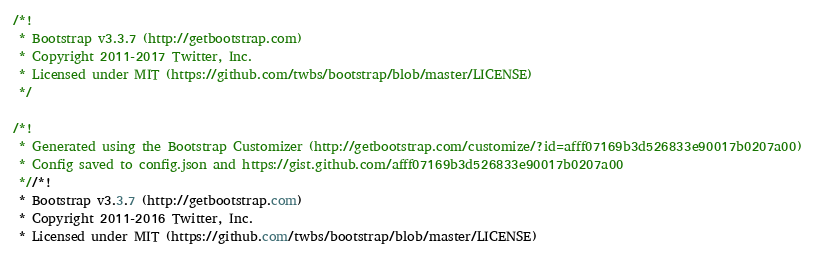<code> <loc_0><loc_0><loc_500><loc_500><_CSS_>/*!
 * Bootstrap v3.3.7 (http://getbootstrap.com)
 * Copyright 2011-2017 Twitter, Inc.
 * Licensed under MIT (https://github.com/twbs/bootstrap/blob/master/LICENSE)
 */

/*!
 * Generated using the Bootstrap Customizer (http://getbootstrap.com/customize/?id=afff07169b3d526833e90017b0207a00)
 * Config saved to config.json and https://gist.github.com/afff07169b3d526833e90017b0207a00
 *//*!
 * Bootstrap v3.3.7 (http://getbootstrap.com)
 * Copyright 2011-2016 Twitter, Inc.
 * Licensed under MIT (https://github.com/twbs/bootstrap/blob/master/LICENSE)</code> 